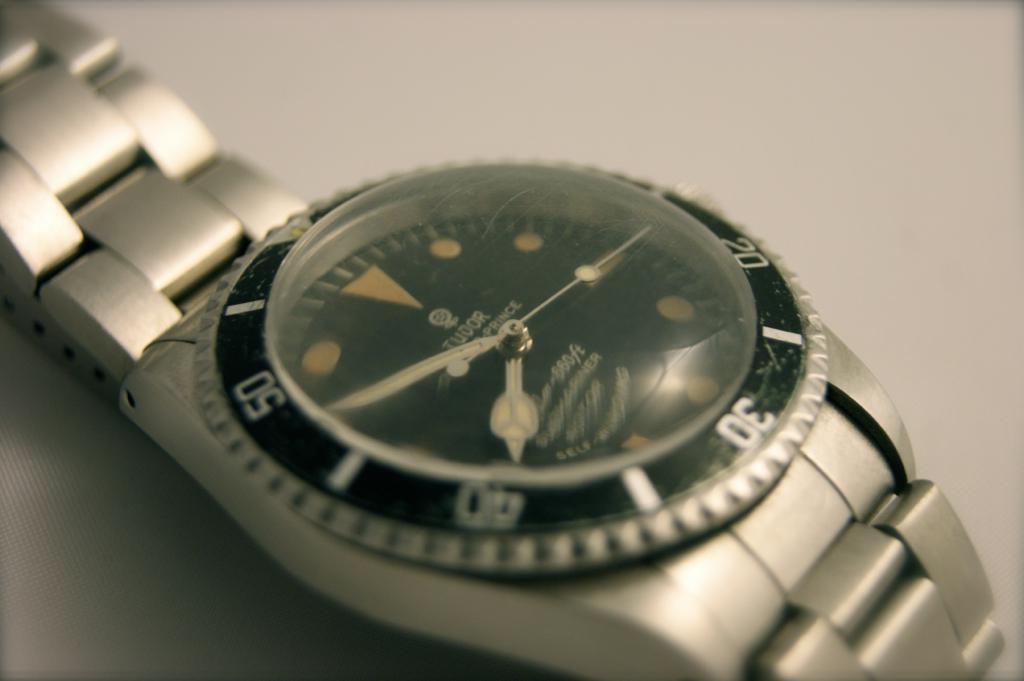What company name is on the watch?
Keep it short and to the point. Tudor. How many feet can this watch go down to?
Provide a succinct answer. 660. 